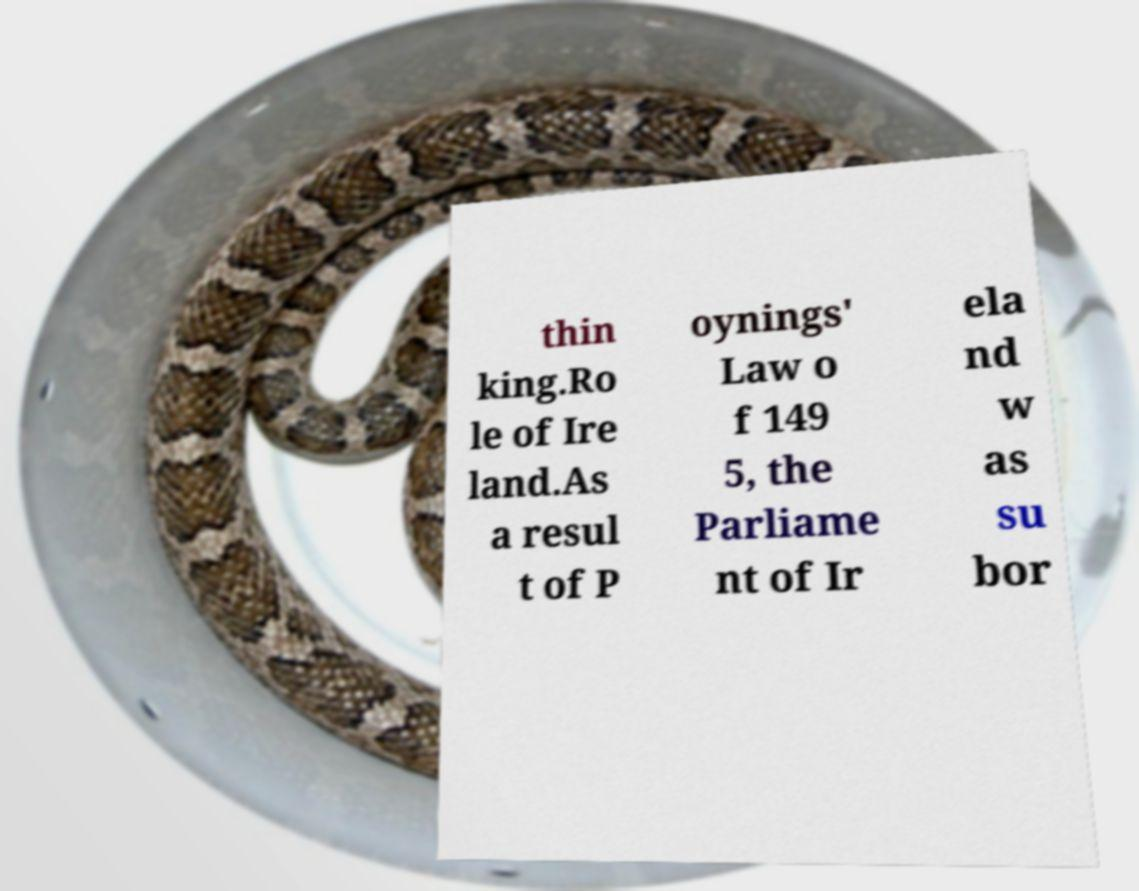For documentation purposes, I need the text within this image transcribed. Could you provide that? thin king.Ro le of Ire land.As a resul t of P oynings' Law o f 149 5, the Parliame nt of Ir ela nd w as su bor 